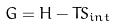Convert formula to latex. <formula><loc_0><loc_0><loc_500><loc_500>G = H - T S _ { i n t }</formula> 